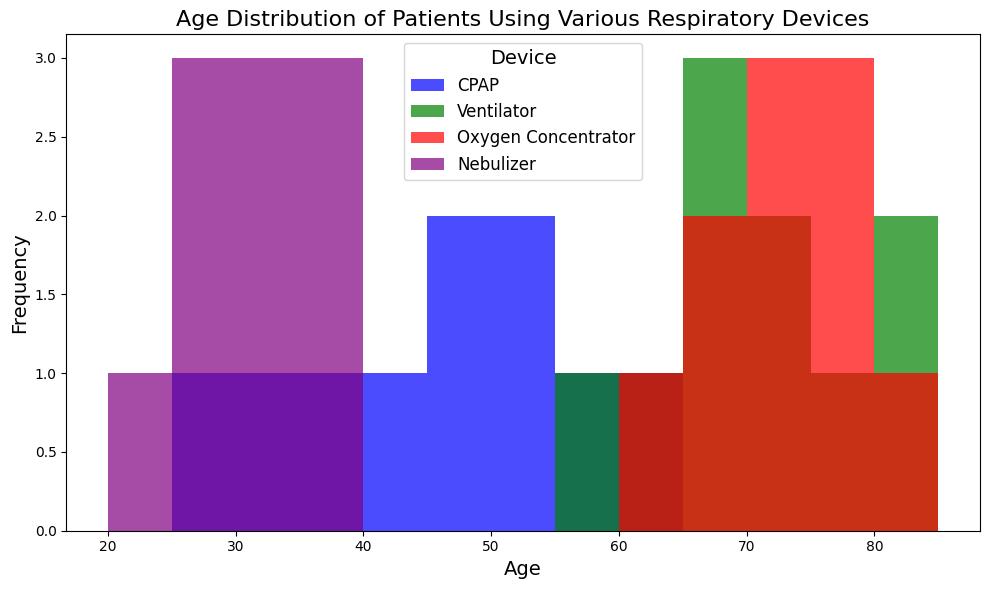What age group has the highest frequency of patients using CPAP devices? Look at the blue bars in the CPAP section of the histogram. Identify which bar is the tallest to determine the age group with the highest frequency.
Answer: 50-55 Compare the age distribution of patients using Ventilators and Oxygen Concentrators. Which group shows a wider age range? Look at the green bars for Ventilators and red bars for Oxygen Concentrators. Determine the starting and ending age ranges for both devices and compare their spans.
Answer: Ventilators What is the median age range for patients using Nebulizers? To find the median age range, look for the purple bars representing Nebulizers and identify the middle age range in terms of frequency distribution.
Answer: 30-35 Which respiratory device is used by patients in the age group of 20-25? Identify the bars that fall within the age range of 20-25 and note the colors and respective respiratory devices they represent.
Answer: Nebulizer Is there any overlap in the age range of patients using Ventilators and CPAP devices? Look at the green bars for Ventilators and blue bars for CPAP devices and see if there are any age ranges where both colors are present.
Answer: No Which device has the highest number of patients in the 70-75 age group? Identify the bars in the age range of 70-75 and note the color of the tallest bar to determine the device.
Answer: Oxygen Concentrator Compare the average age of patients using Ventilators to those using CPAP. Which group is older on average? Calculate the average age by summing the ages and dividing by the number of patients for both groups, then compare the averages. Ventilators ages: 65, 72, 58, 81, 77, 69, 74, 66, 85, 61. CPAP ages: 45, 52, 36, 55, 28, 60, 41, 33, 47, 50. Ventilators average = (65+72+58+81+77+69+74+66+85+61)/10 = 70.8; CPAP average = (45+52+36+55+28+60+41+33+47+50)/10 = 44.7.
Answer: Ventilators Do patients using Oxygen Concentrators and Ventilators fall within the same age ranges? Compare the age ranges for red bars (Oxygen Concentrators) and green bars (Ventilators) to see if their age ranges overlap.
Answer: Yes Which age group has the lowest frequency of patients using any respiratory device? Identify the age group with the smallest combined number of bars across all colors.
Answer: 20-25 How does the age distribution of patients using Nebulizers compare to those using CPAP devices? Compare the purple and blue bars in the histogram. Note the differences and similarities in terms of age ranges and frequency heights.
Answer: Nebulizers show a younger age distribution compared to CPAP 